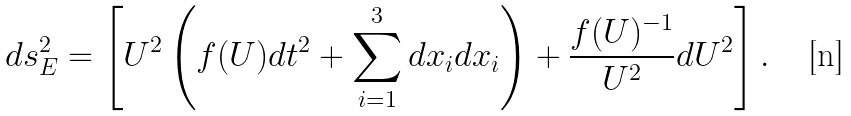<formula> <loc_0><loc_0><loc_500><loc_500>d s _ { E } ^ { 2 } = \left [ U ^ { 2 } \left ( f ( U ) d t ^ { 2 } + \sum ^ { 3 } _ { i = 1 } d x _ { i } d x _ { i } \right ) + \frac { f ( U ) ^ { - 1 } } { U ^ { 2 } } d U ^ { 2 } \right ] .</formula> 